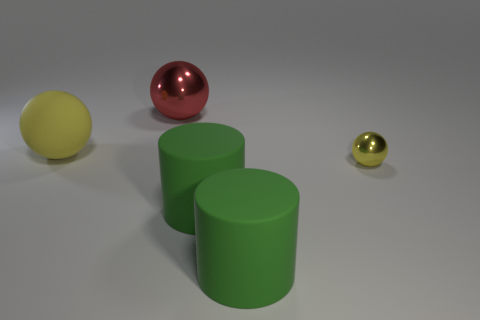There is a yellow thing that is the same size as the red metallic thing; what is it made of?
Make the answer very short. Rubber. Is the shape of the big thing left of the large red thing the same as  the red object?
Your response must be concise. Yes. Is the rubber sphere the same color as the large metallic thing?
Make the answer very short. No. How many objects are metal balls behind the tiny shiny sphere or large red metallic balls?
Give a very brief answer. 1. There is a yellow matte object that is the same size as the red thing; what is its shape?
Provide a succinct answer. Sphere. Do the metallic ball behind the large yellow matte object and the ball that is in front of the big matte ball have the same size?
Offer a terse response. No. What color is the other object that is made of the same material as the red thing?
Your response must be concise. Yellow. Are the red object that is behind the small yellow ball and the ball right of the red metallic sphere made of the same material?
Provide a short and direct response. Yes. Is there another red object of the same size as the red metal thing?
Your answer should be compact. No. There is a yellow thing to the right of the yellow ball left of the yellow metal sphere; how big is it?
Your answer should be very brief. Small. 